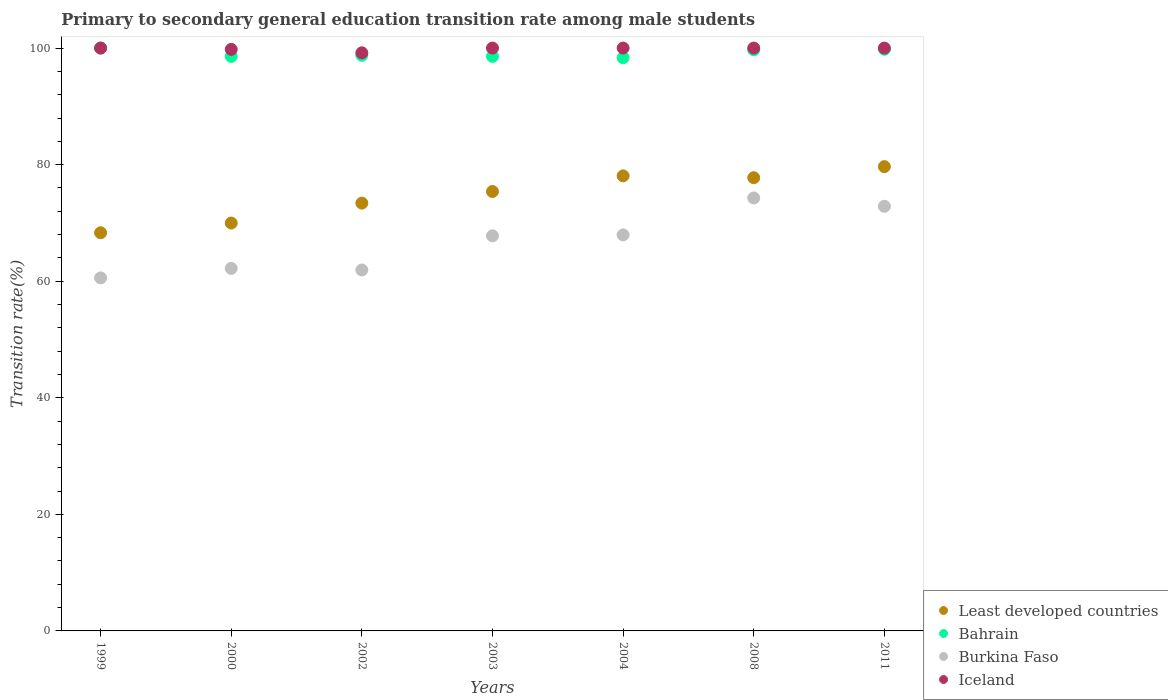How many different coloured dotlines are there?
Keep it short and to the point. 4. Is the number of dotlines equal to the number of legend labels?
Your response must be concise. Yes. Across all years, what is the maximum transition rate in Burkina Faso?
Your response must be concise. 74.28. Across all years, what is the minimum transition rate in Iceland?
Provide a succinct answer. 99.18. In which year was the transition rate in Iceland minimum?
Your answer should be very brief. 2002. What is the total transition rate in Burkina Faso in the graph?
Provide a succinct answer. 467.56. What is the difference between the transition rate in Iceland in 2002 and that in 2008?
Give a very brief answer. -0.82. What is the difference between the transition rate in Burkina Faso in 2011 and the transition rate in Iceland in 1999?
Your answer should be compact. -27.15. What is the average transition rate in Least developed countries per year?
Provide a succinct answer. 74.65. In the year 2004, what is the difference between the transition rate in Burkina Faso and transition rate in Bahrain?
Give a very brief answer. -30.4. What is the ratio of the transition rate in Iceland in 2004 to that in 2008?
Give a very brief answer. 1. Is the difference between the transition rate in Burkina Faso in 2003 and 2011 greater than the difference between the transition rate in Bahrain in 2003 and 2011?
Offer a very short reply. No. What is the difference between the highest and the second highest transition rate in Burkina Faso?
Your answer should be compact. 1.43. What is the difference between the highest and the lowest transition rate in Burkina Faso?
Offer a very short reply. 13.72. Is it the case that in every year, the sum of the transition rate in Burkina Faso and transition rate in Least developed countries  is greater than the sum of transition rate in Iceland and transition rate in Bahrain?
Keep it short and to the point. No. How many dotlines are there?
Provide a short and direct response. 4. How many years are there in the graph?
Provide a succinct answer. 7. What is the difference between two consecutive major ticks on the Y-axis?
Provide a short and direct response. 20. Are the values on the major ticks of Y-axis written in scientific E-notation?
Your answer should be very brief. No. Does the graph contain any zero values?
Your answer should be very brief. No. Where does the legend appear in the graph?
Give a very brief answer. Bottom right. How are the legend labels stacked?
Offer a very short reply. Vertical. What is the title of the graph?
Provide a short and direct response. Primary to secondary general education transition rate among male students. Does "United Arab Emirates" appear as one of the legend labels in the graph?
Provide a succinct answer. No. What is the label or title of the Y-axis?
Your response must be concise. Transition rate(%). What is the Transition rate(%) of Least developed countries in 1999?
Provide a succinct answer. 68.31. What is the Transition rate(%) in Bahrain in 1999?
Provide a succinct answer. 100. What is the Transition rate(%) in Burkina Faso in 1999?
Your answer should be very brief. 60.57. What is the Transition rate(%) in Iceland in 1999?
Make the answer very short. 100. What is the Transition rate(%) in Least developed countries in 2000?
Your answer should be compact. 69.98. What is the Transition rate(%) in Bahrain in 2000?
Provide a short and direct response. 98.57. What is the Transition rate(%) in Burkina Faso in 2000?
Your answer should be very brief. 62.2. What is the Transition rate(%) of Iceland in 2000?
Your answer should be compact. 99.77. What is the Transition rate(%) of Least developed countries in 2002?
Ensure brevity in your answer.  73.4. What is the Transition rate(%) in Bahrain in 2002?
Your answer should be compact. 98.76. What is the Transition rate(%) of Burkina Faso in 2002?
Your response must be concise. 61.93. What is the Transition rate(%) of Iceland in 2002?
Your response must be concise. 99.18. What is the Transition rate(%) in Least developed countries in 2003?
Your answer should be very brief. 75.39. What is the Transition rate(%) in Bahrain in 2003?
Keep it short and to the point. 98.57. What is the Transition rate(%) of Burkina Faso in 2003?
Give a very brief answer. 67.78. What is the Transition rate(%) of Iceland in 2003?
Provide a short and direct response. 100. What is the Transition rate(%) in Least developed countries in 2004?
Make the answer very short. 78.08. What is the Transition rate(%) of Bahrain in 2004?
Your answer should be compact. 98.35. What is the Transition rate(%) of Burkina Faso in 2004?
Offer a terse response. 67.95. What is the Transition rate(%) in Least developed countries in 2008?
Provide a short and direct response. 77.76. What is the Transition rate(%) in Bahrain in 2008?
Your response must be concise. 99.71. What is the Transition rate(%) of Burkina Faso in 2008?
Your response must be concise. 74.28. What is the Transition rate(%) in Least developed countries in 2011?
Make the answer very short. 79.66. What is the Transition rate(%) of Bahrain in 2011?
Make the answer very short. 99.79. What is the Transition rate(%) in Burkina Faso in 2011?
Provide a succinct answer. 72.85. What is the Transition rate(%) of Iceland in 2011?
Provide a succinct answer. 100. Across all years, what is the maximum Transition rate(%) in Least developed countries?
Offer a terse response. 79.66. Across all years, what is the maximum Transition rate(%) in Burkina Faso?
Provide a short and direct response. 74.28. Across all years, what is the maximum Transition rate(%) of Iceland?
Give a very brief answer. 100. Across all years, what is the minimum Transition rate(%) of Least developed countries?
Offer a very short reply. 68.31. Across all years, what is the minimum Transition rate(%) in Bahrain?
Give a very brief answer. 98.35. Across all years, what is the minimum Transition rate(%) of Burkina Faso?
Provide a short and direct response. 60.57. Across all years, what is the minimum Transition rate(%) of Iceland?
Your answer should be very brief. 99.18. What is the total Transition rate(%) in Least developed countries in the graph?
Make the answer very short. 522.58. What is the total Transition rate(%) in Bahrain in the graph?
Your answer should be very brief. 693.75. What is the total Transition rate(%) of Burkina Faso in the graph?
Your answer should be compact. 467.56. What is the total Transition rate(%) of Iceland in the graph?
Provide a short and direct response. 698.95. What is the difference between the Transition rate(%) in Least developed countries in 1999 and that in 2000?
Offer a very short reply. -1.67. What is the difference between the Transition rate(%) in Bahrain in 1999 and that in 2000?
Offer a terse response. 1.43. What is the difference between the Transition rate(%) in Burkina Faso in 1999 and that in 2000?
Your answer should be compact. -1.63. What is the difference between the Transition rate(%) in Iceland in 1999 and that in 2000?
Your answer should be very brief. 0.23. What is the difference between the Transition rate(%) in Least developed countries in 1999 and that in 2002?
Your response must be concise. -5.09. What is the difference between the Transition rate(%) of Bahrain in 1999 and that in 2002?
Give a very brief answer. 1.24. What is the difference between the Transition rate(%) in Burkina Faso in 1999 and that in 2002?
Make the answer very short. -1.36. What is the difference between the Transition rate(%) in Iceland in 1999 and that in 2002?
Your answer should be very brief. 0.82. What is the difference between the Transition rate(%) in Least developed countries in 1999 and that in 2003?
Provide a succinct answer. -7.08. What is the difference between the Transition rate(%) of Bahrain in 1999 and that in 2003?
Provide a short and direct response. 1.43. What is the difference between the Transition rate(%) of Burkina Faso in 1999 and that in 2003?
Keep it short and to the point. -7.22. What is the difference between the Transition rate(%) in Iceland in 1999 and that in 2003?
Your response must be concise. 0. What is the difference between the Transition rate(%) in Least developed countries in 1999 and that in 2004?
Offer a very short reply. -9.76. What is the difference between the Transition rate(%) of Bahrain in 1999 and that in 2004?
Offer a terse response. 1.65. What is the difference between the Transition rate(%) of Burkina Faso in 1999 and that in 2004?
Keep it short and to the point. -7.38. What is the difference between the Transition rate(%) of Iceland in 1999 and that in 2004?
Offer a very short reply. 0. What is the difference between the Transition rate(%) of Least developed countries in 1999 and that in 2008?
Provide a succinct answer. -9.45. What is the difference between the Transition rate(%) in Bahrain in 1999 and that in 2008?
Your response must be concise. 0.29. What is the difference between the Transition rate(%) of Burkina Faso in 1999 and that in 2008?
Offer a terse response. -13.72. What is the difference between the Transition rate(%) in Least developed countries in 1999 and that in 2011?
Make the answer very short. -11.35. What is the difference between the Transition rate(%) in Bahrain in 1999 and that in 2011?
Offer a terse response. 0.21. What is the difference between the Transition rate(%) of Burkina Faso in 1999 and that in 2011?
Ensure brevity in your answer.  -12.28. What is the difference between the Transition rate(%) of Iceland in 1999 and that in 2011?
Your answer should be compact. 0. What is the difference between the Transition rate(%) in Least developed countries in 2000 and that in 2002?
Provide a succinct answer. -3.42. What is the difference between the Transition rate(%) of Bahrain in 2000 and that in 2002?
Keep it short and to the point. -0.19. What is the difference between the Transition rate(%) in Burkina Faso in 2000 and that in 2002?
Keep it short and to the point. 0.27. What is the difference between the Transition rate(%) in Iceland in 2000 and that in 2002?
Provide a succinct answer. 0.59. What is the difference between the Transition rate(%) of Least developed countries in 2000 and that in 2003?
Your answer should be very brief. -5.41. What is the difference between the Transition rate(%) of Bahrain in 2000 and that in 2003?
Provide a succinct answer. -0. What is the difference between the Transition rate(%) of Burkina Faso in 2000 and that in 2003?
Keep it short and to the point. -5.59. What is the difference between the Transition rate(%) in Iceland in 2000 and that in 2003?
Offer a very short reply. -0.23. What is the difference between the Transition rate(%) of Least developed countries in 2000 and that in 2004?
Give a very brief answer. -8.1. What is the difference between the Transition rate(%) of Bahrain in 2000 and that in 2004?
Provide a succinct answer. 0.22. What is the difference between the Transition rate(%) in Burkina Faso in 2000 and that in 2004?
Provide a short and direct response. -5.75. What is the difference between the Transition rate(%) in Iceland in 2000 and that in 2004?
Your response must be concise. -0.23. What is the difference between the Transition rate(%) in Least developed countries in 2000 and that in 2008?
Offer a very short reply. -7.78. What is the difference between the Transition rate(%) of Bahrain in 2000 and that in 2008?
Offer a terse response. -1.13. What is the difference between the Transition rate(%) in Burkina Faso in 2000 and that in 2008?
Provide a short and direct response. -12.09. What is the difference between the Transition rate(%) in Iceland in 2000 and that in 2008?
Your answer should be very brief. -0.23. What is the difference between the Transition rate(%) of Least developed countries in 2000 and that in 2011?
Give a very brief answer. -9.68. What is the difference between the Transition rate(%) in Bahrain in 2000 and that in 2011?
Ensure brevity in your answer.  -1.22. What is the difference between the Transition rate(%) in Burkina Faso in 2000 and that in 2011?
Ensure brevity in your answer.  -10.65. What is the difference between the Transition rate(%) of Iceland in 2000 and that in 2011?
Your response must be concise. -0.23. What is the difference between the Transition rate(%) of Least developed countries in 2002 and that in 2003?
Keep it short and to the point. -1.99. What is the difference between the Transition rate(%) of Bahrain in 2002 and that in 2003?
Offer a terse response. 0.18. What is the difference between the Transition rate(%) of Burkina Faso in 2002 and that in 2003?
Provide a succinct answer. -5.86. What is the difference between the Transition rate(%) in Iceland in 2002 and that in 2003?
Your response must be concise. -0.82. What is the difference between the Transition rate(%) in Least developed countries in 2002 and that in 2004?
Ensure brevity in your answer.  -4.68. What is the difference between the Transition rate(%) of Bahrain in 2002 and that in 2004?
Offer a very short reply. 0.41. What is the difference between the Transition rate(%) of Burkina Faso in 2002 and that in 2004?
Make the answer very short. -6.02. What is the difference between the Transition rate(%) of Iceland in 2002 and that in 2004?
Make the answer very short. -0.82. What is the difference between the Transition rate(%) in Least developed countries in 2002 and that in 2008?
Your answer should be compact. -4.36. What is the difference between the Transition rate(%) in Bahrain in 2002 and that in 2008?
Make the answer very short. -0.95. What is the difference between the Transition rate(%) of Burkina Faso in 2002 and that in 2008?
Provide a succinct answer. -12.36. What is the difference between the Transition rate(%) in Iceland in 2002 and that in 2008?
Your answer should be compact. -0.82. What is the difference between the Transition rate(%) of Least developed countries in 2002 and that in 2011?
Ensure brevity in your answer.  -6.26. What is the difference between the Transition rate(%) in Bahrain in 2002 and that in 2011?
Ensure brevity in your answer.  -1.03. What is the difference between the Transition rate(%) in Burkina Faso in 2002 and that in 2011?
Your answer should be compact. -10.93. What is the difference between the Transition rate(%) in Iceland in 2002 and that in 2011?
Make the answer very short. -0.82. What is the difference between the Transition rate(%) of Least developed countries in 2003 and that in 2004?
Your answer should be very brief. -2.68. What is the difference between the Transition rate(%) of Bahrain in 2003 and that in 2004?
Your answer should be very brief. 0.23. What is the difference between the Transition rate(%) of Burkina Faso in 2003 and that in 2004?
Your answer should be compact. -0.16. What is the difference between the Transition rate(%) in Least developed countries in 2003 and that in 2008?
Your answer should be very brief. -2.37. What is the difference between the Transition rate(%) of Bahrain in 2003 and that in 2008?
Your answer should be very brief. -1.13. What is the difference between the Transition rate(%) of Burkina Faso in 2003 and that in 2008?
Provide a short and direct response. -6.5. What is the difference between the Transition rate(%) in Iceland in 2003 and that in 2008?
Make the answer very short. 0. What is the difference between the Transition rate(%) of Least developed countries in 2003 and that in 2011?
Provide a succinct answer. -4.27. What is the difference between the Transition rate(%) in Bahrain in 2003 and that in 2011?
Your answer should be very brief. -1.22. What is the difference between the Transition rate(%) in Burkina Faso in 2003 and that in 2011?
Your response must be concise. -5.07. What is the difference between the Transition rate(%) in Least developed countries in 2004 and that in 2008?
Ensure brevity in your answer.  0.31. What is the difference between the Transition rate(%) in Bahrain in 2004 and that in 2008?
Your answer should be very brief. -1.36. What is the difference between the Transition rate(%) of Burkina Faso in 2004 and that in 2008?
Keep it short and to the point. -6.34. What is the difference between the Transition rate(%) in Iceland in 2004 and that in 2008?
Provide a short and direct response. 0. What is the difference between the Transition rate(%) in Least developed countries in 2004 and that in 2011?
Offer a very short reply. -1.59. What is the difference between the Transition rate(%) of Bahrain in 2004 and that in 2011?
Ensure brevity in your answer.  -1.45. What is the difference between the Transition rate(%) in Burkina Faso in 2004 and that in 2011?
Ensure brevity in your answer.  -4.9. What is the difference between the Transition rate(%) in Iceland in 2004 and that in 2011?
Your response must be concise. 0. What is the difference between the Transition rate(%) of Least developed countries in 2008 and that in 2011?
Make the answer very short. -1.9. What is the difference between the Transition rate(%) in Bahrain in 2008 and that in 2011?
Your response must be concise. -0.09. What is the difference between the Transition rate(%) in Burkina Faso in 2008 and that in 2011?
Offer a terse response. 1.43. What is the difference between the Transition rate(%) in Least developed countries in 1999 and the Transition rate(%) in Bahrain in 2000?
Your response must be concise. -30.26. What is the difference between the Transition rate(%) in Least developed countries in 1999 and the Transition rate(%) in Burkina Faso in 2000?
Keep it short and to the point. 6.11. What is the difference between the Transition rate(%) in Least developed countries in 1999 and the Transition rate(%) in Iceland in 2000?
Give a very brief answer. -31.46. What is the difference between the Transition rate(%) of Bahrain in 1999 and the Transition rate(%) of Burkina Faso in 2000?
Your answer should be compact. 37.8. What is the difference between the Transition rate(%) in Bahrain in 1999 and the Transition rate(%) in Iceland in 2000?
Ensure brevity in your answer.  0.23. What is the difference between the Transition rate(%) of Burkina Faso in 1999 and the Transition rate(%) of Iceland in 2000?
Provide a succinct answer. -39.2. What is the difference between the Transition rate(%) in Least developed countries in 1999 and the Transition rate(%) in Bahrain in 2002?
Provide a succinct answer. -30.45. What is the difference between the Transition rate(%) of Least developed countries in 1999 and the Transition rate(%) of Burkina Faso in 2002?
Your answer should be compact. 6.39. What is the difference between the Transition rate(%) of Least developed countries in 1999 and the Transition rate(%) of Iceland in 2002?
Offer a very short reply. -30.87. What is the difference between the Transition rate(%) of Bahrain in 1999 and the Transition rate(%) of Burkina Faso in 2002?
Provide a succinct answer. 38.07. What is the difference between the Transition rate(%) of Bahrain in 1999 and the Transition rate(%) of Iceland in 2002?
Make the answer very short. 0.82. What is the difference between the Transition rate(%) in Burkina Faso in 1999 and the Transition rate(%) in Iceland in 2002?
Make the answer very short. -38.61. What is the difference between the Transition rate(%) in Least developed countries in 1999 and the Transition rate(%) in Bahrain in 2003?
Give a very brief answer. -30.26. What is the difference between the Transition rate(%) in Least developed countries in 1999 and the Transition rate(%) in Burkina Faso in 2003?
Ensure brevity in your answer.  0.53. What is the difference between the Transition rate(%) in Least developed countries in 1999 and the Transition rate(%) in Iceland in 2003?
Your response must be concise. -31.69. What is the difference between the Transition rate(%) of Bahrain in 1999 and the Transition rate(%) of Burkina Faso in 2003?
Provide a succinct answer. 32.22. What is the difference between the Transition rate(%) in Burkina Faso in 1999 and the Transition rate(%) in Iceland in 2003?
Your response must be concise. -39.43. What is the difference between the Transition rate(%) in Least developed countries in 1999 and the Transition rate(%) in Bahrain in 2004?
Offer a very short reply. -30.03. What is the difference between the Transition rate(%) in Least developed countries in 1999 and the Transition rate(%) in Burkina Faso in 2004?
Keep it short and to the point. 0.36. What is the difference between the Transition rate(%) in Least developed countries in 1999 and the Transition rate(%) in Iceland in 2004?
Keep it short and to the point. -31.69. What is the difference between the Transition rate(%) in Bahrain in 1999 and the Transition rate(%) in Burkina Faso in 2004?
Your answer should be very brief. 32.05. What is the difference between the Transition rate(%) of Bahrain in 1999 and the Transition rate(%) of Iceland in 2004?
Make the answer very short. 0. What is the difference between the Transition rate(%) in Burkina Faso in 1999 and the Transition rate(%) in Iceland in 2004?
Your answer should be compact. -39.43. What is the difference between the Transition rate(%) of Least developed countries in 1999 and the Transition rate(%) of Bahrain in 2008?
Ensure brevity in your answer.  -31.39. What is the difference between the Transition rate(%) of Least developed countries in 1999 and the Transition rate(%) of Burkina Faso in 2008?
Keep it short and to the point. -5.97. What is the difference between the Transition rate(%) of Least developed countries in 1999 and the Transition rate(%) of Iceland in 2008?
Your answer should be compact. -31.69. What is the difference between the Transition rate(%) in Bahrain in 1999 and the Transition rate(%) in Burkina Faso in 2008?
Ensure brevity in your answer.  25.72. What is the difference between the Transition rate(%) in Burkina Faso in 1999 and the Transition rate(%) in Iceland in 2008?
Make the answer very short. -39.43. What is the difference between the Transition rate(%) of Least developed countries in 1999 and the Transition rate(%) of Bahrain in 2011?
Keep it short and to the point. -31.48. What is the difference between the Transition rate(%) in Least developed countries in 1999 and the Transition rate(%) in Burkina Faso in 2011?
Your answer should be very brief. -4.54. What is the difference between the Transition rate(%) of Least developed countries in 1999 and the Transition rate(%) of Iceland in 2011?
Ensure brevity in your answer.  -31.69. What is the difference between the Transition rate(%) of Bahrain in 1999 and the Transition rate(%) of Burkina Faso in 2011?
Make the answer very short. 27.15. What is the difference between the Transition rate(%) of Bahrain in 1999 and the Transition rate(%) of Iceland in 2011?
Your answer should be compact. 0. What is the difference between the Transition rate(%) of Burkina Faso in 1999 and the Transition rate(%) of Iceland in 2011?
Your response must be concise. -39.43. What is the difference between the Transition rate(%) in Least developed countries in 2000 and the Transition rate(%) in Bahrain in 2002?
Provide a short and direct response. -28.78. What is the difference between the Transition rate(%) of Least developed countries in 2000 and the Transition rate(%) of Burkina Faso in 2002?
Your answer should be very brief. 8.05. What is the difference between the Transition rate(%) of Least developed countries in 2000 and the Transition rate(%) of Iceland in 2002?
Your answer should be very brief. -29.2. What is the difference between the Transition rate(%) in Bahrain in 2000 and the Transition rate(%) in Burkina Faso in 2002?
Keep it short and to the point. 36.65. What is the difference between the Transition rate(%) of Bahrain in 2000 and the Transition rate(%) of Iceland in 2002?
Give a very brief answer. -0.61. What is the difference between the Transition rate(%) of Burkina Faso in 2000 and the Transition rate(%) of Iceland in 2002?
Keep it short and to the point. -36.98. What is the difference between the Transition rate(%) of Least developed countries in 2000 and the Transition rate(%) of Bahrain in 2003?
Keep it short and to the point. -28.59. What is the difference between the Transition rate(%) in Least developed countries in 2000 and the Transition rate(%) in Burkina Faso in 2003?
Provide a succinct answer. 2.2. What is the difference between the Transition rate(%) in Least developed countries in 2000 and the Transition rate(%) in Iceland in 2003?
Keep it short and to the point. -30.02. What is the difference between the Transition rate(%) of Bahrain in 2000 and the Transition rate(%) of Burkina Faso in 2003?
Provide a succinct answer. 30.79. What is the difference between the Transition rate(%) of Bahrain in 2000 and the Transition rate(%) of Iceland in 2003?
Make the answer very short. -1.43. What is the difference between the Transition rate(%) of Burkina Faso in 2000 and the Transition rate(%) of Iceland in 2003?
Offer a very short reply. -37.8. What is the difference between the Transition rate(%) in Least developed countries in 2000 and the Transition rate(%) in Bahrain in 2004?
Offer a very short reply. -28.37. What is the difference between the Transition rate(%) in Least developed countries in 2000 and the Transition rate(%) in Burkina Faso in 2004?
Provide a succinct answer. 2.03. What is the difference between the Transition rate(%) of Least developed countries in 2000 and the Transition rate(%) of Iceland in 2004?
Provide a short and direct response. -30.02. What is the difference between the Transition rate(%) in Bahrain in 2000 and the Transition rate(%) in Burkina Faso in 2004?
Provide a succinct answer. 30.62. What is the difference between the Transition rate(%) in Bahrain in 2000 and the Transition rate(%) in Iceland in 2004?
Offer a terse response. -1.43. What is the difference between the Transition rate(%) in Burkina Faso in 2000 and the Transition rate(%) in Iceland in 2004?
Provide a short and direct response. -37.8. What is the difference between the Transition rate(%) of Least developed countries in 2000 and the Transition rate(%) of Bahrain in 2008?
Provide a succinct answer. -29.73. What is the difference between the Transition rate(%) in Least developed countries in 2000 and the Transition rate(%) in Burkina Faso in 2008?
Make the answer very short. -4.3. What is the difference between the Transition rate(%) in Least developed countries in 2000 and the Transition rate(%) in Iceland in 2008?
Your answer should be compact. -30.02. What is the difference between the Transition rate(%) of Bahrain in 2000 and the Transition rate(%) of Burkina Faso in 2008?
Make the answer very short. 24.29. What is the difference between the Transition rate(%) in Bahrain in 2000 and the Transition rate(%) in Iceland in 2008?
Ensure brevity in your answer.  -1.43. What is the difference between the Transition rate(%) in Burkina Faso in 2000 and the Transition rate(%) in Iceland in 2008?
Make the answer very short. -37.8. What is the difference between the Transition rate(%) of Least developed countries in 2000 and the Transition rate(%) of Bahrain in 2011?
Offer a terse response. -29.81. What is the difference between the Transition rate(%) in Least developed countries in 2000 and the Transition rate(%) in Burkina Faso in 2011?
Provide a succinct answer. -2.87. What is the difference between the Transition rate(%) of Least developed countries in 2000 and the Transition rate(%) of Iceland in 2011?
Provide a succinct answer. -30.02. What is the difference between the Transition rate(%) in Bahrain in 2000 and the Transition rate(%) in Burkina Faso in 2011?
Ensure brevity in your answer.  25.72. What is the difference between the Transition rate(%) of Bahrain in 2000 and the Transition rate(%) of Iceland in 2011?
Your answer should be compact. -1.43. What is the difference between the Transition rate(%) of Burkina Faso in 2000 and the Transition rate(%) of Iceland in 2011?
Your answer should be compact. -37.8. What is the difference between the Transition rate(%) of Least developed countries in 2002 and the Transition rate(%) of Bahrain in 2003?
Your answer should be very brief. -25.18. What is the difference between the Transition rate(%) in Least developed countries in 2002 and the Transition rate(%) in Burkina Faso in 2003?
Offer a terse response. 5.62. What is the difference between the Transition rate(%) of Least developed countries in 2002 and the Transition rate(%) of Iceland in 2003?
Keep it short and to the point. -26.6. What is the difference between the Transition rate(%) of Bahrain in 2002 and the Transition rate(%) of Burkina Faso in 2003?
Ensure brevity in your answer.  30.98. What is the difference between the Transition rate(%) of Bahrain in 2002 and the Transition rate(%) of Iceland in 2003?
Make the answer very short. -1.24. What is the difference between the Transition rate(%) of Burkina Faso in 2002 and the Transition rate(%) of Iceland in 2003?
Make the answer very short. -38.07. What is the difference between the Transition rate(%) in Least developed countries in 2002 and the Transition rate(%) in Bahrain in 2004?
Keep it short and to the point. -24.95. What is the difference between the Transition rate(%) in Least developed countries in 2002 and the Transition rate(%) in Burkina Faso in 2004?
Your response must be concise. 5.45. What is the difference between the Transition rate(%) of Least developed countries in 2002 and the Transition rate(%) of Iceland in 2004?
Offer a very short reply. -26.6. What is the difference between the Transition rate(%) of Bahrain in 2002 and the Transition rate(%) of Burkina Faso in 2004?
Provide a short and direct response. 30.81. What is the difference between the Transition rate(%) in Bahrain in 2002 and the Transition rate(%) in Iceland in 2004?
Your response must be concise. -1.24. What is the difference between the Transition rate(%) of Burkina Faso in 2002 and the Transition rate(%) of Iceland in 2004?
Make the answer very short. -38.07. What is the difference between the Transition rate(%) in Least developed countries in 2002 and the Transition rate(%) in Bahrain in 2008?
Provide a succinct answer. -26.31. What is the difference between the Transition rate(%) of Least developed countries in 2002 and the Transition rate(%) of Burkina Faso in 2008?
Offer a very short reply. -0.88. What is the difference between the Transition rate(%) in Least developed countries in 2002 and the Transition rate(%) in Iceland in 2008?
Your answer should be very brief. -26.6. What is the difference between the Transition rate(%) of Bahrain in 2002 and the Transition rate(%) of Burkina Faso in 2008?
Your answer should be compact. 24.47. What is the difference between the Transition rate(%) of Bahrain in 2002 and the Transition rate(%) of Iceland in 2008?
Keep it short and to the point. -1.24. What is the difference between the Transition rate(%) of Burkina Faso in 2002 and the Transition rate(%) of Iceland in 2008?
Keep it short and to the point. -38.07. What is the difference between the Transition rate(%) of Least developed countries in 2002 and the Transition rate(%) of Bahrain in 2011?
Give a very brief answer. -26.39. What is the difference between the Transition rate(%) in Least developed countries in 2002 and the Transition rate(%) in Burkina Faso in 2011?
Offer a very short reply. 0.55. What is the difference between the Transition rate(%) in Least developed countries in 2002 and the Transition rate(%) in Iceland in 2011?
Your response must be concise. -26.6. What is the difference between the Transition rate(%) in Bahrain in 2002 and the Transition rate(%) in Burkina Faso in 2011?
Your answer should be compact. 25.91. What is the difference between the Transition rate(%) of Bahrain in 2002 and the Transition rate(%) of Iceland in 2011?
Offer a very short reply. -1.24. What is the difference between the Transition rate(%) in Burkina Faso in 2002 and the Transition rate(%) in Iceland in 2011?
Keep it short and to the point. -38.07. What is the difference between the Transition rate(%) of Least developed countries in 2003 and the Transition rate(%) of Bahrain in 2004?
Provide a succinct answer. -22.95. What is the difference between the Transition rate(%) of Least developed countries in 2003 and the Transition rate(%) of Burkina Faso in 2004?
Offer a very short reply. 7.44. What is the difference between the Transition rate(%) in Least developed countries in 2003 and the Transition rate(%) in Iceland in 2004?
Keep it short and to the point. -24.61. What is the difference between the Transition rate(%) in Bahrain in 2003 and the Transition rate(%) in Burkina Faso in 2004?
Offer a terse response. 30.63. What is the difference between the Transition rate(%) in Bahrain in 2003 and the Transition rate(%) in Iceland in 2004?
Make the answer very short. -1.43. What is the difference between the Transition rate(%) in Burkina Faso in 2003 and the Transition rate(%) in Iceland in 2004?
Your response must be concise. -32.22. What is the difference between the Transition rate(%) of Least developed countries in 2003 and the Transition rate(%) of Bahrain in 2008?
Your response must be concise. -24.31. What is the difference between the Transition rate(%) in Least developed countries in 2003 and the Transition rate(%) in Burkina Faso in 2008?
Your answer should be very brief. 1.11. What is the difference between the Transition rate(%) in Least developed countries in 2003 and the Transition rate(%) in Iceland in 2008?
Ensure brevity in your answer.  -24.61. What is the difference between the Transition rate(%) in Bahrain in 2003 and the Transition rate(%) in Burkina Faso in 2008?
Keep it short and to the point. 24.29. What is the difference between the Transition rate(%) in Bahrain in 2003 and the Transition rate(%) in Iceland in 2008?
Provide a succinct answer. -1.43. What is the difference between the Transition rate(%) of Burkina Faso in 2003 and the Transition rate(%) of Iceland in 2008?
Your answer should be very brief. -32.22. What is the difference between the Transition rate(%) of Least developed countries in 2003 and the Transition rate(%) of Bahrain in 2011?
Provide a short and direct response. -24.4. What is the difference between the Transition rate(%) of Least developed countries in 2003 and the Transition rate(%) of Burkina Faso in 2011?
Make the answer very short. 2.54. What is the difference between the Transition rate(%) in Least developed countries in 2003 and the Transition rate(%) in Iceland in 2011?
Your answer should be very brief. -24.61. What is the difference between the Transition rate(%) of Bahrain in 2003 and the Transition rate(%) of Burkina Faso in 2011?
Your answer should be very brief. 25.72. What is the difference between the Transition rate(%) of Bahrain in 2003 and the Transition rate(%) of Iceland in 2011?
Keep it short and to the point. -1.43. What is the difference between the Transition rate(%) in Burkina Faso in 2003 and the Transition rate(%) in Iceland in 2011?
Provide a succinct answer. -32.22. What is the difference between the Transition rate(%) in Least developed countries in 2004 and the Transition rate(%) in Bahrain in 2008?
Offer a terse response. -21.63. What is the difference between the Transition rate(%) of Least developed countries in 2004 and the Transition rate(%) of Burkina Faso in 2008?
Ensure brevity in your answer.  3.79. What is the difference between the Transition rate(%) in Least developed countries in 2004 and the Transition rate(%) in Iceland in 2008?
Make the answer very short. -21.93. What is the difference between the Transition rate(%) in Bahrain in 2004 and the Transition rate(%) in Burkina Faso in 2008?
Provide a short and direct response. 24.06. What is the difference between the Transition rate(%) of Bahrain in 2004 and the Transition rate(%) of Iceland in 2008?
Offer a very short reply. -1.65. What is the difference between the Transition rate(%) in Burkina Faso in 2004 and the Transition rate(%) in Iceland in 2008?
Your response must be concise. -32.05. What is the difference between the Transition rate(%) in Least developed countries in 2004 and the Transition rate(%) in Bahrain in 2011?
Your answer should be compact. -21.72. What is the difference between the Transition rate(%) of Least developed countries in 2004 and the Transition rate(%) of Burkina Faso in 2011?
Your response must be concise. 5.22. What is the difference between the Transition rate(%) in Least developed countries in 2004 and the Transition rate(%) in Iceland in 2011?
Your response must be concise. -21.93. What is the difference between the Transition rate(%) of Bahrain in 2004 and the Transition rate(%) of Burkina Faso in 2011?
Give a very brief answer. 25.49. What is the difference between the Transition rate(%) of Bahrain in 2004 and the Transition rate(%) of Iceland in 2011?
Ensure brevity in your answer.  -1.65. What is the difference between the Transition rate(%) of Burkina Faso in 2004 and the Transition rate(%) of Iceland in 2011?
Give a very brief answer. -32.05. What is the difference between the Transition rate(%) of Least developed countries in 2008 and the Transition rate(%) of Bahrain in 2011?
Your answer should be very brief. -22.03. What is the difference between the Transition rate(%) of Least developed countries in 2008 and the Transition rate(%) of Burkina Faso in 2011?
Your answer should be compact. 4.91. What is the difference between the Transition rate(%) of Least developed countries in 2008 and the Transition rate(%) of Iceland in 2011?
Your answer should be very brief. -22.24. What is the difference between the Transition rate(%) in Bahrain in 2008 and the Transition rate(%) in Burkina Faso in 2011?
Provide a succinct answer. 26.85. What is the difference between the Transition rate(%) of Bahrain in 2008 and the Transition rate(%) of Iceland in 2011?
Your answer should be compact. -0.29. What is the difference between the Transition rate(%) of Burkina Faso in 2008 and the Transition rate(%) of Iceland in 2011?
Your answer should be compact. -25.72. What is the average Transition rate(%) in Least developed countries per year?
Offer a very short reply. 74.65. What is the average Transition rate(%) in Bahrain per year?
Your answer should be compact. 99.11. What is the average Transition rate(%) in Burkina Faso per year?
Offer a terse response. 66.79. What is the average Transition rate(%) of Iceland per year?
Provide a short and direct response. 99.85. In the year 1999, what is the difference between the Transition rate(%) in Least developed countries and Transition rate(%) in Bahrain?
Your response must be concise. -31.69. In the year 1999, what is the difference between the Transition rate(%) in Least developed countries and Transition rate(%) in Burkina Faso?
Offer a terse response. 7.74. In the year 1999, what is the difference between the Transition rate(%) in Least developed countries and Transition rate(%) in Iceland?
Offer a terse response. -31.69. In the year 1999, what is the difference between the Transition rate(%) of Bahrain and Transition rate(%) of Burkina Faso?
Offer a very short reply. 39.43. In the year 1999, what is the difference between the Transition rate(%) in Bahrain and Transition rate(%) in Iceland?
Offer a very short reply. 0. In the year 1999, what is the difference between the Transition rate(%) of Burkina Faso and Transition rate(%) of Iceland?
Your response must be concise. -39.43. In the year 2000, what is the difference between the Transition rate(%) in Least developed countries and Transition rate(%) in Bahrain?
Make the answer very short. -28.59. In the year 2000, what is the difference between the Transition rate(%) of Least developed countries and Transition rate(%) of Burkina Faso?
Keep it short and to the point. 7.78. In the year 2000, what is the difference between the Transition rate(%) in Least developed countries and Transition rate(%) in Iceland?
Your answer should be very brief. -29.79. In the year 2000, what is the difference between the Transition rate(%) in Bahrain and Transition rate(%) in Burkina Faso?
Provide a short and direct response. 36.37. In the year 2000, what is the difference between the Transition rate(%) in Bahrain and Transition rate(%) in Iceland?
Offer a very short reply. -1.2. In the year 2000, what is the difference between the Transition rate(%) of Burkina Faso and Transition rate(%) of Iceland?
Give a very brief answer. -37.57. In the year 2002, what is the difference between the Transition rate(%) of Least developed countries and Transition rate(%) of Bahrain?
Your answer should be compact. -25.36. In the year 2002, what is the difference between the Transition rate(%) of Least developed countries and Transition rate(%) of Burkina Faso?
Provide a short and direct response. 11.47. In the year 2002, what is the difference between the Transition rate(%) in Least developed countries and Transition rate(%) in Iceland?
Make the answer very short. -25.78. In the year 2002, what is the difference between the Transition rate(%) of Bahrain and Transition rate(%) of Burkina Faso?
Provide a succinct answer. 36.83. In the year 2002, what is the difference between the Transition rate(%) in Bahrain and Transition rate(%) in Iceland?
Offer a very short reply. -0.42. In the year 2002, what is the difference between the Transition rate(%) of Burkina Faso and Transition rate(%) of Iceland?
Your answer should be very brief. -37.25. In the year 2003, what is the difference between the Transition rate(%) of Least developed countries and Transition rate(%) of Bahrain?
Ensure brevity in your answer.  -23.18. In the year 2003, what is the difference between the Transition rate(%) of Least developed countries and Transition rate(%) of Burkina Faso?
Your response must be concise. 7.61. In the year 2003, what is the difference between the Transition rate(%) in Least developed countries and Transition rate(%) in Iceland?
Ensure brevity in your answer.  -24.61. In the year 2003, what is the difference between the Transition rate(%) in Bahrain and Transition rate(%) in Burkina Faso?
Provide a short and direct response. 30.79. In the year 2003, what is the difference between the Transition rate(%) in Bahrain and Transition rate(%) in Iceland?
Ensure brevity in your answer.  -1.43. In the year 2003, what is the difference between the Transition rate(%) in Burkina Faso and Transition rate(%) in Iceland?
Your answer should be compact. -32.22. In the year 2004, what is the difference between the Transition rate(%) in Least developed countries and Transition rate(%) in Bahrain?
Your answer should be very brief. -20.27. In the year 2004, what is the difference between the Transition rate(%) of Least developed countries and Transition rate(%) of Burkina Faso?
Ensure brevity in your answer.  10.13. In the year 2004, what is the difference between the Transition rate(%) in Least developed countries and Transition rate(%) in Iceland?
Offer a terse response. -21.93. In the year 2004, what is the difference between the Transition rate(%) in Bahrain and Transition rate(%) in Burkina Faso?
Your answer should be compact. 30.4. In the year 2004, what is the difference between the Transition rate(%) in Bahrain and Transition rate(%) in Iceland?
Offer a very short reply. -1.65. In the year 2004, what is the difference between the Transition rate(%) in Burkina Faso and Transition rate(%) in Iceland?
Offer a terse response. -32.05. In the year 2008, what is the difference between the Transition rate(%) of Least developed countries and Transition rate(%) of Bahrain?
Offer a very short reply. -21.94. In the year 2008, what is the difference between the Transition rate(%) of Least developed countries and Transition rate(%) of Burkina Faso?
Provide a short and direct response. 3.48. In the year 2008, what is the difference between the Transition rate(%) of Least developed countries and Transition rate(%) of Iceland?
Offer a very short reply. -22.24. In the year 2008, what is the difference between the Transition rate(%) of Bahrain and Transition rate(%) of Burkina Faso?
Provide a succinct answer. 25.42. In the year 2008, what is the difference between the Transition rate(%) in Bahrain and Transition rate(%) in Iceland?
Your answer should be very brief. -0.29. In the year 2008, what is the difference between the Transition rate(%) of Burkina Faso and Transition rate(%) of Iceland?
Provide a short and direct response. -25.72. In the year 2011, what is the difference between the Transition rate(%) in Least developed countries and Transition rate(%) in Bahrain?
Your response must be concise. -20.13. In the year 2011, what is the difference between the Transition rate(%) in Least developed countries and Transition rate(%) in Burkina Faso?
Provide a succinct answer. 6.81. In the year 2011, what is the difference between the Transition rate(%) of Least developed countries and Transition rate(%) of Iceland?
Offer a very short reply. -20.34. In the year 2011, what is the difference between the Transition rate(%) of Bahrain and Transition rate(%) of Burkina Faso?
Your answer should be very brief. 26.94. In the year 2011, what is the difference between the Transition rate(%) of Bahrain and Transition rate(%) of Iceland?
Your answer should be compact. -0.21. In the year 2011, what is the difference between the Transition rate(%) of Burkina Faso and Transition rate(%) of Iceland?
Make the answer very short. -27.15. What is the ratio of the Transition rate(%) in Least developed countries in 1999 to that in 2000?
Your answer should be compact. 0.98. What is the ratio of the Transition rate(%) in Bahrain in 1999 to that in 2000?
Your answer should be compact. 1.01. What is the ratio of the Transition rate(%) of Burkina Faso in 1999 to that in 2000?
Your answer should be very brief. 0.97. What is the ratio of the Transition rate(%) of Least developed countries in 1999 to that in 2002?
Your answer should be compact. 0.93. What is the ratio of the Transition rate(%) of Bahrain in 1999 to that in 2002?
Make the answer very short. 1.01. What is the ratio of the Transition rate(%) in Burkina Faso in 1999 to that in 2002?
Keep it short and to the point. 0.98. What is the ratio of the Transition rate(%) in Iceland in 1999 to that in 2002?
Your response must be concise. 1.01. What is the ratio of the Transition rate(%) in Least developed countries in 1999 to that in 2003?
Make the answer very short. 0.91. What is the ratio of the Transition rate(%) of Bahrain in 1999 to that in 2003?
Give a very brief answer. 1.01. What is the ratio of the Transition rate(%) in Burkina Faso in 1999 to that in 2003?
Offer a terse response. 0.89. What is the ratio of the Transition rate(%) of Bahrain in 1999 to that in 2004?
Keep it short and to the point. 1.02. What is the ratio of the Transition rate(%) in Burkina Faso in 1999 to that in 2004?
Give a very brief answer. 0.89. What is the ratio of the Transition rate(%) of Least developed countries in 1999 to that in 2008?
Offer a terse response. 0.88. What is the ratio of the Transition rate(%) in Bahrain in 1999 to that in 2008?
Give a very brief answer. 1. What is the ratio of the Transition rate(%) in Burkina Faso in 1999 to that in 2008?
Give a very brief answer. 0.82. What is the ratio of the Transition rate(%) in Iceland in 1999 to that in 2008?
Make the answer very short. 1. What is the ratio of the Transition rate(%) of Least developed countries in 1999 to that in 2011?
Your answer should be compact. 0.86. What is the ratio of the Transition rate(%) in Bahrain in 1999 to that in 2011?
Offer a very short reply. 1. What is the ratio of the Transition rate(%) in Burkina Faso in 1999 to that in 2011?
Your answer should be very brief. 0.83. What is the ratio of the Transition rate(%) of Iceland in 1999 to that in 2011?
Your answer should be compact. 1. What is the ratio of the Transition rate(%) in Least developed countries in 2000 to that in 2002?
Provide a succinct answer. 0.95. What is the ratio of the Transition rate(%) in Bahrain in 2000 to that in 2002?
Provide a short and direct response. 1. What is the ratio of the Transition rate(%) of Least developed countries in 2000 to that in 2003?
Make the answer very short. 0.93. What is the ratio of the Transition rate(%) in Burkina Faso in 2000 to that in 2003?
Your response must be concise. 0.92. What is the ratio of the Transition rate(%) in Least developed countries in 2000 to that in 2004?
Your response must be concise. 0.9. What is the ratio of the Transition rate(%) in Bahrain in 2000 to that in 2004?
Offer a very short reply. 1. What is the ratio of the Transition rate(%) of Burkina Faso in 2000 to that in 2004?
Keep it short and to the point. 0.92. What is the ratio of the Transition rate(%) in Least developed countries in 2000 to that in 2008?
Keep it short and to the point. 0.9. What is the ratio of the Transition rate(%) of Bahrain in 2000 to that in 2008?
Your answer should be very brief. 0.99. What is the ratio of the Transition rate(%) in Burkina Faso in 2000 to that in 2008?
Keep it short and to the point. 0.84. What is the ratio of the Transition rate(%) in Least developed countries in 2000 to that in 2011?
Give a very brief answer. 0.88. What is the ratio of the Transition rate(%) in Burkina Faso in 2000 to that in 2011?
Provide a succinct answer. 0.85. What is the ratio of the Transition rate(%) of Iceland in 2000 to that in 2011?
Give a very brief answer. 1. What is the ratio of the Transition rate(%) in Least developed countries in 2002 to that in 2003?
Your response must be concise. 0.97. What is the ratio of the Transition rate(%) of Bahrain in 2002 to that in 2003?
Your answer should be compact. 1. What is the ratio of the Transition rate(%) in Burkina Faso in 2002 to that in 2003?
Your response must be concise. 0.91. What is the ratio of the Transition rate(%) of Least developed countries in 2002 to that in 2004?
Provide a succinct answer. 0.94. What is the ratio of the Transition rate(%) in Bahrain in 2002 to that in 2004?
Provide a short and direct response. 1. What is the ratio of the Transition rate(%) in Burkina Faso in 2002 to that in 2004?
Make the answer very short. 0.91. What is the ratio of the Transition rate(%) in Least developed countries in 2002 to that in 2008?
Provide a short and direct response. 0.94. What is the ratio of the Transition rate(%) in Burkina Faso in 2002 to that in 2008?
Your response must be concise. 0.83. What is the ratio of the Transition rate(%) of Iceland in 2002 to that in 2008?
Provide a succinct answer. 0.99. What is the ratio of the Transition rate(%) of Least developed countries in 2002 to that in 2011?
Offer a terse response. 0.92. What is the ratio of the Transition rate(%) in Bahrain in 2002 to that in 2011?
Make the answer very short. 0.99. What is the ratio of the Transition rate(%) in Burkina Faso in 2002 to that in 2011?
Your answer should be very brief. 0.85. What is the ratio of the Transition rate(%) of Least developed countries in 2003 to that in 2004?
Give a very brief answer. 0.97. What is the ratio of the Transition rate(%) in Burkina Faso in 2003 to that in 2004?
Provide a short and direct response. 1. What is the ratio of the Transition rate(%) in Least developed countries in 2003 to that in 2008?
Your response must be concise. 0.97. What is the ratio of the Transition rate(%) of Bahrain in 2003 to that in 2008?
Your answer should be very brief. 0.99. What is the ratio of the Transition rate(%) in Burkina Faso in 2003 to that in 2008?
Your answer should be very brief. 0.91. What is the ratio of the Transition rate(%) of Least developed countries in 2003 to that in 2011?
Ensure brevity in your answer.  0.95. What is the ratio of the Transition rate(%) of Bahrain in 2003 to that in 2011?
Give a very brief answer. 0.99. What is the ratio of the Transition rate(%) in Burkina Faso in 2003 to that in 2011?
Give a very brief answer. 0.93. What is the ratio of the Transition rate(%) of Least developed countries in 2004 to that in 2008?
Keep it short and to the point. 1. What is the ratio of the Transition rate(%) of Bahrain in 2004 to that in 2008?
Your answer should be very brief. 0.99. What is the ratio of the Transition rate(%) of Burkina Faso in 2004 to that in 2008?
Offer a very short reply. 0.91. What is the ratio of the Transition rate(%) of Least developed countries in 2004 to that in 2011?
Offer a very short reply. 0.98. What is the ratio of the Transition rate(%) of Bahrain in 2004 to that in 2011?
Give a very brief answer. 0.99. What is the ratio of the Transition rate(%) in Burkina Faso in 2004 to that in 2011?
Offer a terse response. 0.93. What is the ratio of the Transition rate(%) of Iceland in 2004 to that in 2011?
Provide a succinct answer. 1. What is the ratio of the Transition rate(%) in Least developed countries in 2008 to that in 2011?
Offer a very short reply. 0.98. What is the ratio of the Transition rate(%) of Burkina Faso in 2008 to that in 2011?
Your answer should be compact. 1.02. What is the difference between the highest and the second highest Transition rate(%) of Least developed countries?
Give a very brief answer. 1.59. What is the difference between the highest and the second highest Transition rate(%) in Bahrain?
Your answer should be very brief. 0.21. What is the difference between the highest and the second highest Transition rate(%) of Burkina Faso?
Provide a short and direct response. 1.43. What is the difference between the highest and the second highest Transition rate(%) of Iceland?
Keep it short and to the point. 0. What is the difference between the highest and the lowest Transition rate(%) of Least developed countries?
Your answer should be compact. 11.35. What is the difference between the highest and the lowest Transition rate(%) in Bahrain?
Offer a very short reply. 1.65. What is the difference between the highest and the lowest Transition rate(%) in Burkina Faso?
Your answer should be very brief. 13.72. What is the difference between the highest and the lowest Transition rate(%) in Iceland?
Give a very brief answer. 0.82. 